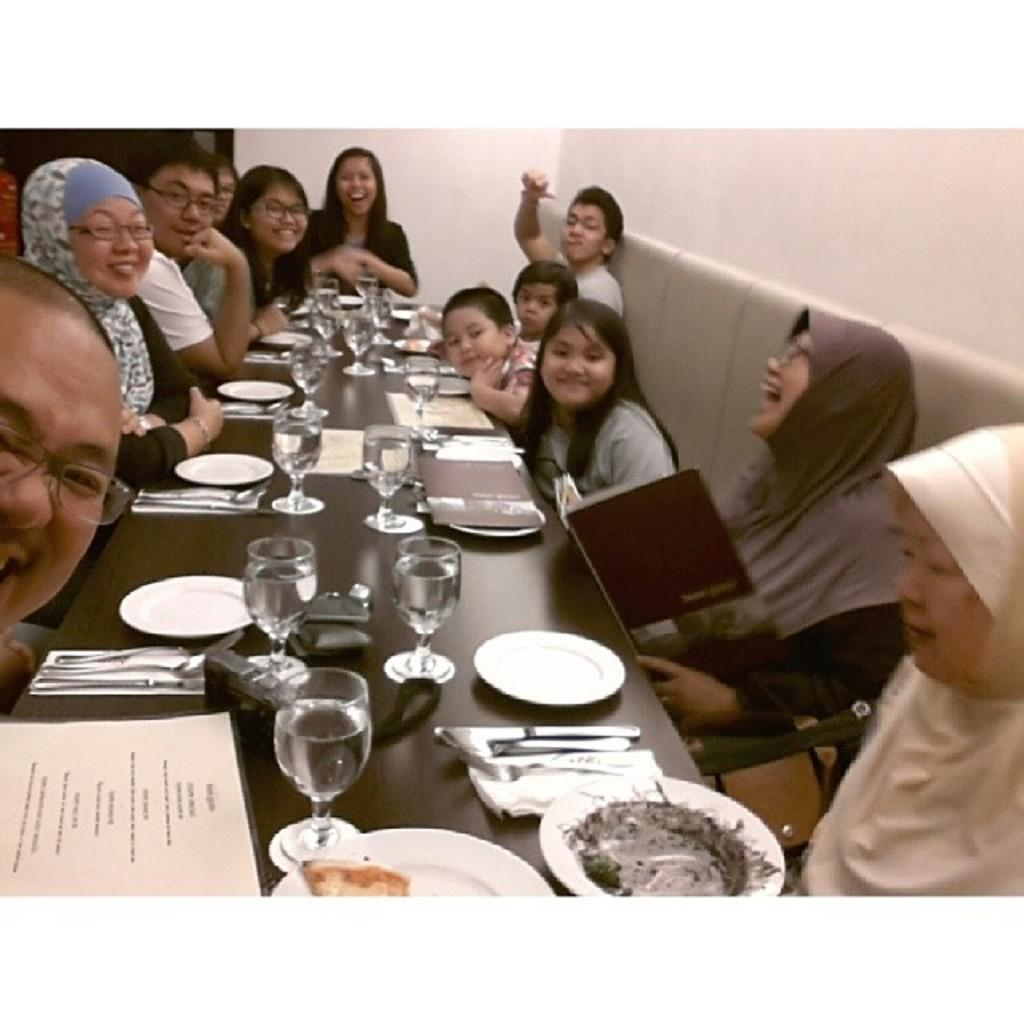What are the people in the image doing? The persons in the image are sitting on chairs. What is present on the table in the image? There are plates, glasses, and spoons on the table. What is the background of the image? There is a wall in the background of the image. What type of wood is used to construct the wall in the image? There is no information about the type of wood used to construct the wall in the image. 